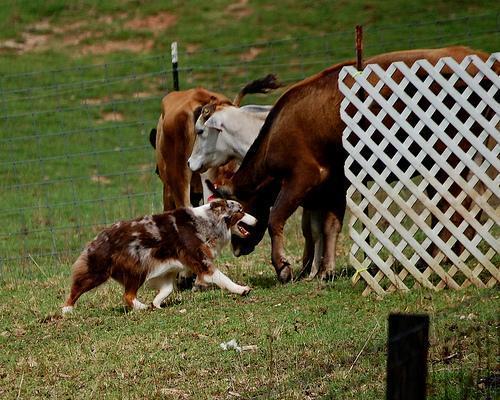How many dogs are in the photo?
Give a very brief answer. 1. 